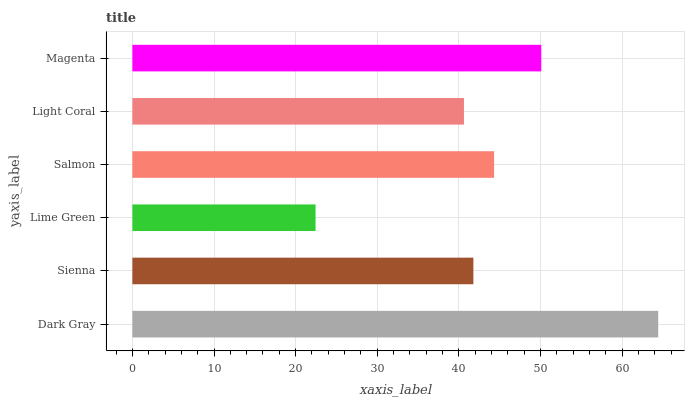Is Lime Green the minimum?
Answer yes or no. Yes. Is Dark Gray the maximum?
Answer yes or no. Yes. Is Sienna the minimum?
Answer yes or no. No. Is Sienna the maximum?
Answer yes or no. No. Is Dark Gray greater than Sienna?
Answer yes or no. Yes. Is Sienna less than Dark Gray?
Answer yes or no. Yes. Is Sienna greater than Dark Gray?
Answer yes or no. No. Is Dark Gray less than Sienna?
Answer yes or no. No. Is Salmon the high median?
Answer yes or no. Yes. Is Sienna the low median?
Answer yes or no. Yes. Is Dark Gray the high median?
Answer yes or no. No. Is Dark Gray the low median?
Answer yes or no. No. 